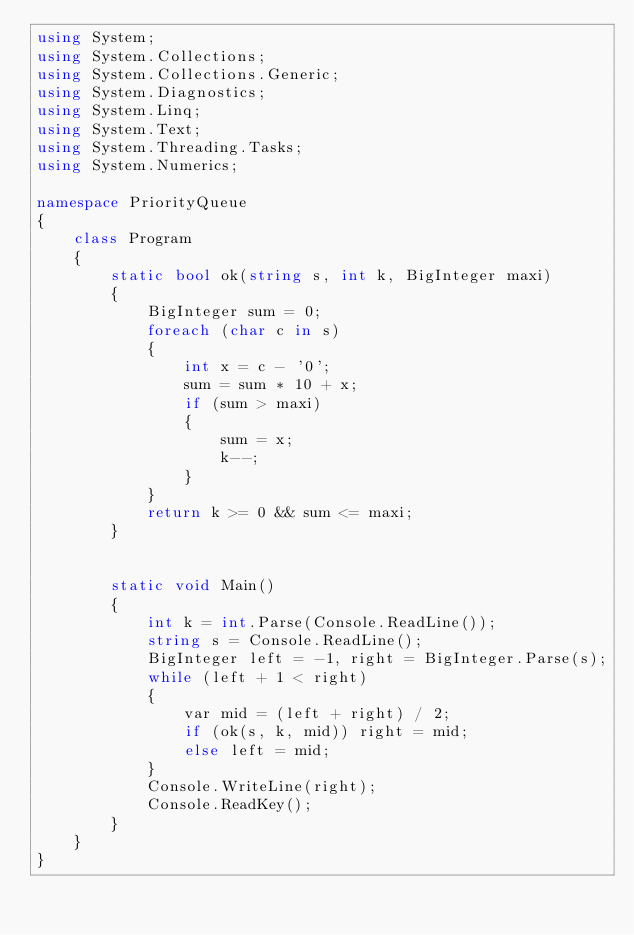Convert code to text. <code><loc_0><loc_0><loc_500><loc_500><_C#_>using System;
using System.Collections;
using System.Collections.Generic;
using System.Diagnostics;
using System.Linq;
using System.Text;
using System.Threading.Tasks;
using System.Numerics;

namespace PriorityQueue
{
    class Program
    {
        static bool ok(string s, int k, BigInteger maxi)
        {
            BigInteger sum = 0;
            foreach (char c in s)
            {
                int x = c - '0';
                sum = sum * 10 + x;
                if (sum > maxi)
                {
                    sum = x;
                    k--;
                }
            }
            return k >= 0 && sum <= maxi;
        }


        static void Main()
        {
            int k = int.Parse(Console.ReadLine());
            string s = Console.ReadLine();
            BigInteger left = -1, right = BigInteger.Parse(s);
            while (left + 1 < right)
            {
                var mid = (left + right) / 2;
                if (ok(s, k, mid)) right = mid;
                else left = mid;
            }
            Console.WriteLine(right);
            Console.ReadKey();
        }
    }
}
</code> 